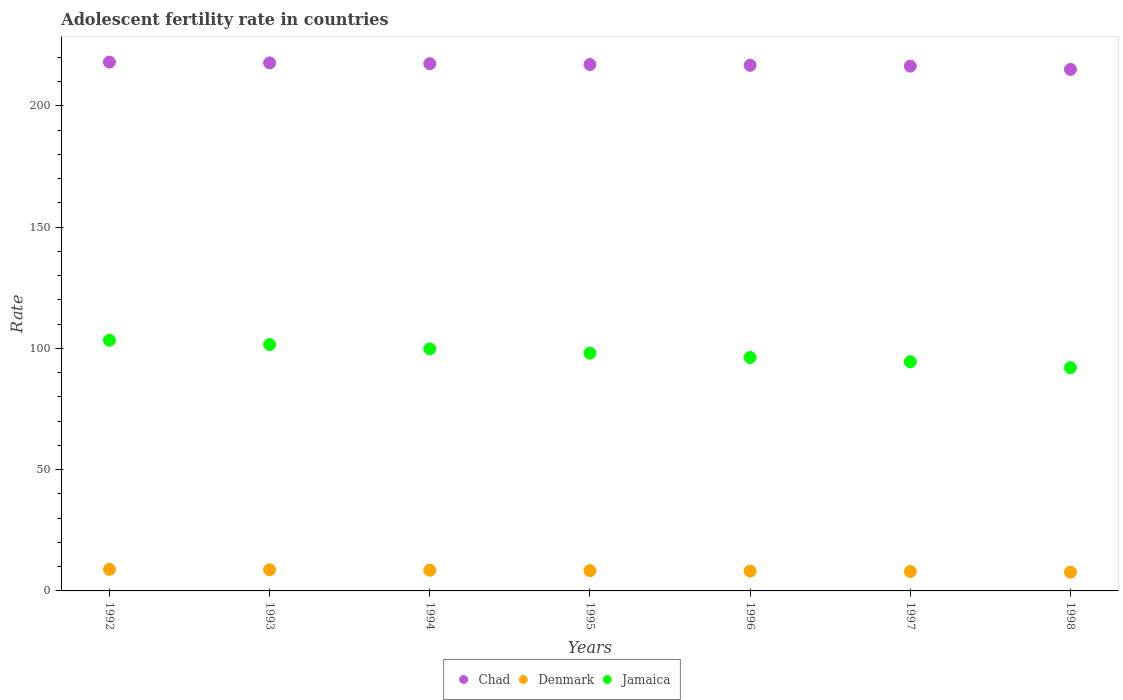How many different coloured dotlines are there?
Ensure brevity in your answer.  3. Is the number of dotlines equal to the number of legend labels?
Provide a short and direct response. Yes. What is the adolescent fertility rate in Denmark in 1997?
Your response must be concise. 8.01. Across all years, what is the maximum adolescent fertility rate in Jamaica?
Keep it short and to the point. 103.38. Across all years, what is the minimum adolescent fertility rate in Chad?
Provide a short and direct response. 215.09. In which year was the adolescent fertility rate in Chad minimum?
Make the answer very short. 1998. What is the total adolescent fertility rate in Jamaica in the graph?
Your answer should be very brief. 685.7. What is the difference between the adolescent fertility rate in Denmark in 1992 and that in 1998?
Keep it short and to the point. 1.17. What is the difference between the adolescent fertility rate in Chad in 1993 and the adolescent fertility rate in Jamaica in 1995?
Provide a succinct answer. 119.71. What is the average adolescent fertility rate in Denmark per year?
Provide a short and direct response. 8.35. In the year 1997, what is the difference between the adolescent fertility rate in Jamaica and adolescent fertility rate in Denmark?
Provide a short and direct response. 86.49. What is the ratio of the adolescent fertility rate in Jamaica in 1992 to that in 1996?
Offer a terse response. 1.07. Is the adolescent fertility rate in Chad in 1992 less than that in 1997?
Ensure brevity in your answer.  No. What is the difference between the highest and the second highest adolescent fertility rate in Chad?
Offer a very short reply. 0.33. What is the difference between the highest and the lowest adolescent fertility rate in Chad?
Ensure brevity in your answer.  3. Is it the case that in every year, the sum of the adolescent fertility rate in Denmark and adolescent fertility rate in Jamaica  is greater than the adolescent fertility rate in Chad?
Provide a short and direct response. No. Does the adolescent fertility rate in Jamaica monotonically increase over the years?
Your answer should be very brief. No. Is the adolescent fertility rate in Jamaica strictly greater than the adolescent fertility rate in Denmark over the years?
Your answer should be very brief. Yes. Is the adolescent fertility rate in Jamaica strictly less than the adolescent fertility rate in Chad over the years?
Ensure brevity in your answer.  Yes. How many years are there in the graph?
Keep it short and to the point. 7. What is the difference between two consecutive major ticks on the Y-axis?
Make the answer very short. 50. Are the values on the major ticks of Y-axis written in scientific E-notation?
Offer a very short reply. No. Does the graph contain any zero values?
Your response must be concise. No. Where does the legend appear in the graph?
Offer a terse response. Bottom center. How many legend labels are there?
Give a very brief answer. 3. How are the legend labels stacked?
Make the answer very short. Horizontal. What is the title of the graph?
Offer a terse response. Adolescent fertility rate in countries. What is the label or title of the Y-axis?
Give a very brief answer. Rate. What is the Rate in Chad in 1992?
Provide a short and direct response. 218.09. What is the Rate of Denmark in 1992?
Keep it short and to the point. 8.9. What is the Rate in Jamaica in 1992?
Keep it short and to the point. 103.38. What is the Rate of Chad in 1993?
Give a very brief answer. 217.76. What is the Rate of Denmark in 1993?
Your response must be concise. 8.72. What is the Rate in Jamaica in 1993?
Your answer should be compact. 101.6. What is the Rate in Chad in 1994?
Your answer should be compact. 217.43. What is the Rate in Denmark in 1994?
Give a very brief answer. 8.54. What is the Rate in Jamaica in 1994?
Ensure brevity in your answer.  99.83. What is the Rate of Chad in 1995?
Your response must be concise. 217.1. What is the Rate of Denmark in 1995?
Your response must be concise. 8.36. What is the Rate of Jamaica in 1995?
Make the answer very short. 98.05. What is the Rate of Chad in 1996?
Ensure brevity in your answer.  216.77. What is the Rate of Denmark in 1996?
Keep it short and to the point. 8.19. What is the Rate of Jamaica in 1996?
Offer a very short reply. 96.28. What is the Rate in Chad in 1997?
Offer a very short reply. 216.43. What is the Rate in Denmark in 1997?
Provide a succinct answer. 8.01. What is the Rate of Jamaica in 1997?
Offer a very short reply. 94.5. What is the Rate of Chad in 1998?
Offer a very short reply. 215.09. What is the Rate in Denmark in 1998?
Your answer should be very brief. 7.73. What is the Rate in Jamaica in 1998?
Ensure brevity in your answer.  92.07. Across all years, what is the maximum Rate in Chad?
Your answer should be compact. 218.09. Across all years, what is the maximum Rate in Denmark?
Keep it short and to the point. 8.9. Across all years, what is the maximum Rate of Jamaica?
Offer a very short reply. 103.38. Across all years, what is the minimum Rate of Chad?
Provide a succinct answer. 215.09. Across all years, what is the minimum Rate of Denmark?
Provide a short and direct response. 7.73. Across all years, what is the minimum Rate in Jamaica?
Give a very brief answer. 92.07. What is the total Rate in Chad in the graph?
Your answer should be compact. 1518.67. What is the total Rate in Denmark in the graph?
Provide a succinct answer. 58.45. What is the total Rate of Jamaica in the graph?
Provide a succinct answer. 685.7. What is the difference between the Rate of Chad in 1992 and that in 1993?
Keep it short and to the point. 0.33. What is the difference between the Rate in Denmark in 1992 and that in 1993?
Your answer should be compact. 0.18. What is the difference between the Rate of Jamaica in 1992 and that in 1993?
Provide a succinct answer. 1.78. What is the difference between the Rate of Chad in 1992 and that in 1994?
Provide a succinct answer. 0.66. What is the difference between the Rate in Denmark in 1992 and that in 1994?
Ensure brevity in your answer.  0.36. What is the difference between the Rate in Jamaica in 1992 and that in 1994?
Your answer should be very brief. 3.55. What is the difference between the Rate in Denmark in 1992 and that in 1995?
Your response must be concise. 0.54. What is the difference between the Rate of Jamaica in 1992 and that in 1995?
Your response must be concise. 5.33. What is the difference between the Rate in Chad in 1992 and that in 1996?
Your response must be concise. 1.33. What is the difference between the Rate in Denmark in 1992 and that in 1996?
Offer a terse response. 0.72. What is the difference between the Rate in Jamaica in 1992 and that in 1996?
Your answer should be compact. 7.1. What is the difference between the Rate in Chad in 1992 and that in 1997?
Ensure brevity in your answer.  1.66. What is the difference between the Rate of Denmark in 1992 and that in 1997?
Your answer should be very brief. 0.89. What is the difference between the Rate of Jamaica in 1992 and that in 1997?
Provide a short and direct response. 8.88. What is the difference between the Rate in Chad in 1992 and that in 1998?
Ensure brevity in your answer.  3. What is the difference between the Rate of Denmark in 1992 and that in 1998?
Keep it short and to the point. 1.17. What is the difference between the Rate of Jamaica in 1992 and that in 1998?
Ensure brevity in your answer.  11.3. What is the difference between the Rate in Chad in 1993 and that in 1994?
Keep it short and to the point. 0.33. What is the difference between the Rate of Denmark in 1993 and that in 1994?
Offer a very short reply. 0.18. What is the difference between the Rate of Jamaica in 1993 and that in 1994?
Your answer should be compact. 1.78. What is the difference between the Rate of Chad in 1993 and that in 1995?
Your response must be concise. 0.66. What is the difference between the Rate in Denmark in 1993 and that in 1995?
Ensure brevity in your answer.  0.36. What is the difference between the Rate of Jamaica in 1993 and that in 1995?
Offer a very short reply. 3.55. What is the difference between the Rate of Denmark in 1993 and that in 1996?
Make the answer very short. 0.54. What is the difference between the Rate of Jamaica in 1993 and that in 1996?
Offer a terse response. 5.33. What is the difference between the Rate of Chad in 1993 and that in 1997?
Offer a very short reply. 1.33. What is the difference between the Rate of Denmark in 1993 and that in 1997?
Your response must be concise. 0.72. What is the difference between the Rate in Jamaica in 1993 and that in 1997?
Provide a succinct answer. 7.1. What is the difference between the Rate of Chad in 1993 and that in 1998?
Provide a short and direct response. 2.67. What is the difference between the Rate of Denmark in 1993 and that in 1998?
Offer a terse response. 0.99. What is the difference between the Rate in Jamaica in 1993 and that in 1998?
Offer a very short reply. 9.53. What is the difference between the Rate in Chad in 1994 and that in 1995?
Keep it short and to the point. 0.33. What is the difference between the Rate of Denmark in 1994 and that in 1995?
Make the answer very short. 0.18. What is the difference between the Rate of Jamaica in 1994 and that in 1995?
Your answer should be very brief. 1.78. What is the difference between the Rate in Chad in 1994 and that in 1996?
Your answer should be compact. 0.66. What is the difference between the Rate of Denmark in 1994 and that in 1996?
Make the answer very short. 0.36. What is the difference between the Rate in Jamaica in 1994 and that in 1996?
Your answer should be very brief. 3.55. What is the difference between the Rate of Chad in 1994 and that in 1997?
Keep it short and to the point. 1. What is the difference between the Rate of Denmark in 1994 and that in 1997?
Provide a succinct answer. 0.54. What is the difference between the Rate of Jamaica in 1994 and that in 1997?
Ensure brevity in your answer.  5.33. What is the difference between the Rate of Chad in 1994 and that in 1998?
Offer a very short reply. 2.34. What is the difference between the Rate in Denmark in 1994 and that in 1998?
Keep it short and to the point. 0.81. What is the difference between the Rate of Jamaica in 1994 and that in 1998?
Keep it short and to the point. 7.75. What is the difference between the Rate of Chad in 1995 and that in 1996?
Your response must be concise. 0.33. What is the difference between the Rate in Denmark in 1995 and that in 1996?
Offer a very short reply. 0.18. What is the difference between the Rate in Jamaica in 1995 and that in 1996?
Offer a very short reply. 1.78. What is the difference between the Rate in Chad in 1995 and that in 1997?
Your response must be concise. 0.66. What is the difference between the Rate of Denmark in 1995 and that in 1997?
Give a very brief answer. 0.36. What is the difference between the Rate in Jamaica in 1995 and that in 1997?
Make the answer very short. 3.55. What is the difference between the Rate of Chad in 1995 and that in 1998?
Offer a terse response. 2.01. What is the difference between the Rate in Denmark in 1995 and that in 1998?
Provide a short and direct response. 0.64. What is the difference between the Rate in Jamaica in 1995 and that in 1998?
Give a very brief answer. 5.98. What is the difference between the Rate of Chad in 1996 and that in 1997?
Offer a terse response. 0.33. What is the difference between the Rate of Denmark in 1996 and that in 1997?
Provide a succinct answer. 0.18. What is the difference between the Rate of Jamaica in 1996 and that in 1997?
Make the answer very short. 1.78. What is the difference between the Rate of Chad in 1996 and that in 1998?
Provide a succinct answer. 1.67. What is the difference between the Rate in Denmark in 1996 and that in 1998?
Make the answer very short. 0.46. What is the difference between the Rate of Jamaica in 1996 and that in 1998?
Make the answer very short. 4.2. What is the difference between the Rate of Chad in 1997 and that in 1998?
Offer a very short reply. 1.34. What is the difference between the Rate of Denmark in 1997 and that in 1998?
Make the answer very short. 0.28. What is the difference between the Rate of Jamaica in 1997 and that in 1998?
Your answer should be very brief. 2.43. What is the difference between the Rate in Chad in 1992 and the Rate in Denmark in 1993?
Offer a very short reply. 209.37. What is the difference between the Rate in Chad in 1992 and the Rate in Jamaica in 1993?
Offer a terse response. 116.49. What is the difference between the Rate in Denmark in 1992 and the Rate in Jamaica in 1993?
Your answer should be compact. -92.7. What is the difference between the Rate in Chad in 1992 and the Rate in Denmark in 1994?
Offer a terse response. 209.55. What is the difference between the Rate of Chad in 1992 and the Rate of Jamaica in 1994?
Keep it short and to the point. 118.27. What is the difference between the Rate of Denmark in 1992 and the Rate of Jamaica in 1994?
Offer a terse response. -90.92. What is the difference between the Rate in Chad in 1992 and the Rate in Denmark in 1995?
Your response must be concise. 209.73. What is the difference between the Rate in Chad in 1992 and the Rate in Jamaica in 1995?
Give a very brief answer. 120.04. What is the difference between the Rate in Denmark in 1992 and the Rate in Jamaica in 1995?
Provide a succinct answer. -89.15. What is the difference between the Rate of Chad in 1992 and the Rate of Denmark in 1996?
Make the answer very short. 209.91. What is the difference between the Rate of Chad in 1992 and the Rate of Jamaica in 1996?
Offer a terse response. 121.82. What is the difference between the Rate in Denmark in 1992 and the Rate in Jamaica in 1996?
Offer a terse response. -87.37. What is the difference between the Rate in Chad in 1992 and the Rate in Denmark in 1997?
Your response must be concise. 210.09. What is the difference between the Rate in Chad in 1992 and the Rate in Jamaica in 1997?
Offer a terse response. 123.59. What is the difference between the Rate in Denmark in 1992 and the Rate in Jamaica in 1997?
Your response must be concise. -85.6. What is the difference between the Rate in Chad in 1992 and the Rate in Denmark in 1998?
Ensure brevity in your answer.  210.36. What is the difference between the Rate of Chad in 1992 and the Rate of Jamaica in 1998?
Ensure brevity in your answer.  126.02. What is the difference between the Rate in Denmark in 1992 and the Rate in Jamaica in 1998?
Provide a succinct answer. -83.17. What is the difference between the Rate of Chad in 1993 and the Rate of Denmark in 1994?
Offer a very short reply. 209.22. What is the difference between the Rate of Chad in 1993 and the Rate of Jamaica in 1994?
Your answer should be compact. 117.94. What is the difference between the Rate of Denmark in 1993 and the Rate of Jamaica in 1994?
Offer a terse response. -91.1. What is the difference between the Rate of Chad in 1993 and the Rate of Denmark in 1995?
Ensure brevity in your answer.  209.4. What is the difference between the Rate in Chad in 1993 and the Rate in Jamaica in 1995?
Your response must be concise. 119.71. What is the difference between the Rate of Denmark in 1993 and the Rate of Jamaica in 1995?
Your answer should be very brief. -89.33. What is the difference between the Rate of Chad in 1993 and the Rate of Denmark in 1996?
Offer a terse response. 209.58. What is the difference between the Rate of Chad in 1993 and the Rate of Jamaica in 1996?
Make the answer very short. 121.49. What is the difference between the Rate in Denmark in 1993 and the Rate in Jamaica in 1996?
Offer a terse response. -87.55. What is the difference between the Rate in Chad in 1993 and the Rate in Denmark in 1997?
Provide a succinct answer. 209.75. What is the difference between the Rate of Chad in 1993 and the Rate of Jamaica in 1997?
Keep it short and to the point. 123.26. What is the difference between the Rate of Denmark in 1993 and the Rate of Jamaica in 1997?
Give a very brief answer. -85.78. What is the difference between the Rate of Chad in 1993 and the Rate of Denmark in 1998?
Provide a short and direct response. 210.03. What is the difference between the Rate in Chad in 1993 and the Rate in Jamaica in 1998?
Provide a succinct answer. 125.69. What is the difference between the Rate in Denmark in 1993 and the Rate in Jamaica in 1998?
Your answer should be very brief. -83.35. What is the difference between the Rate in Chad in 1994 and the Rate in Denmark in 1995?
Keep it short and to the point. 209.06. What is the difference between the Rate of Chad in 1994 and the Rate of Jamaica in 1995?
Your answer should be very brief. 119.38. What is the difference between the Rate in Denmark in 1994 and the Rate in Jamaica in 1995?
Provide a short and direct response. -89.51. What is the difference between the Rate in Chad in 1994 and the Rate in Denmark in 1996?
Your response must be concise. 209.24. What is the difference between the Rate of Chad in 1994 and the Rate of Jamaica in 1996?
Your answer should be very brief. 121.15. What is the difference between the Rate of Denmark in 1994 and the Rate of Jamaica in 1996?
Ensure brevity in your answer.  -87.73. What is the difference between the Rate in Chad in 1994 and the Rate in Denmark in 1997?
Your answer should be very brief. 209.42. What is the difference between the Rate in Chad in 1994 and the Rate in Jamaica in 1997?
Your answer should be very brief. 122.93. What is the difference between the Rate of Denmark in 1994 and the Rate of Jamaica in 1997?
Ensure brevity in your answer.  -85.96. What is the difference between the Rate in Chad in 1994 and the Rate in Denmark in 1998?
Offer a terse response. 209.7. What is the difference between the Rate of Chad in 1994 and the Rate of Jamaica in 1998?
Your answer should be very brief. 125.36. What is the difference between the Rate in Denmark in 1994 and the Rate in Jamaica in 1998?
Your answer should be very brief. -83.53. What is the difference between the Rate of Chad in 1995 and the Rate of Denmark in 1996?
Give a very brief answer. 208.91. What is the difference between the Rate in Chad in 1995 and the Rate in Jamaica in 1996?
Make the answer very short. 120.82. What is the difference between the Rate in Denmark in 1995 and the Rate in Jamaica in 1996?
Keep it short and to the point. -87.91. What is the difference between the Rate of Chad in 1995 and the Rate of Denmark in 1997?
Provide a succinct answer. 209.09. What is the difference between the Rate of Chad in 1995 and the Rate of Jamaica in 1997?
Your answer should be compact. 122.6. What is the difference between the Rate in Denmark in 1995 and the Rate in Jamaica in 1997?
Your answer should be compact. -86.14. What is the difference between the Rate in Chad in 1995 and the Rate in Denmark in 1998?
Provide a succinct answer. 209.37. What is the difference between the Rate of Chad in 1995 and the Rate of Jamaica in 1998?
Give a very brief answer. 125.02. What is the difference between the Rate in Denmark in 1995 and the Rate in Jamaica in 1998?
Make the answer very short. -83.71. What is the difference between the Rate in Chad in 1996 and the Rate in Denmark in 1997?
Make the answer very short. 208.76. What is the difference between the Rate in Chad in 1996 and the Rate in Jamaica in 1997?
Keep it short and to the point. 122.27. What is the difference between the Rate of Denmark in 1996 and the Rate of Jamaica in 1997?
Offer a terse response. -86.31. What is the difference between the Rate of Chad in 1996 and the Rate of Denmark in 1998?
Make the answer very short. 209.04. What is the difference between the Rate of Chad in 1996 and the Rate of Jamaica in 1998?
Offer a terse response. 124.69. What is the difference between the Rate of Denmark in 1996 and the Rate of Jamaica in 1998?
Provide a short and direct response. -83.89. What is the difference between the Rate in Chad in 1997 and the Rate in Denmark in 1998?
Your answer should be compact. 208.7. What is the difference between the Rate in Chad in 1997 and the Rate in Jamaica in 1998?
Make the answer very short. 124.36. What is the difference between the Rate of Denmark in 1997 and the Rate of Jamaica in 1998?
Offer a very short reply. -84.07. What is the average Rate in Chad per year?
Provide a short and direct response. 216.95. What is the average Rate in Denmark per year?
Offer a terse response. 8.35. What is the average Rate of Jamaica per year?
Make the answer very short. 97.96. In the year 1992, what is the difference between the Rate of Chad and Rate of Denmark?
Keep it short and to the point. 209.19. In the year 1992, what is the difference between the Rate in Chad and Rate in Jamaica?
Give a very brief answer. 114.72. In the year 1992, what is the difference between the Rate of Denmark and Rate of Jamaica?
Keep it short and to the point. -94.47. In the year 1993, what is the difference between the Rate of Chad and Rate of Denmark?
Offer a terse response. 209.04. In the year 1993, what is the difference between the Rate in Chad and Rate in Jamaica?
Provide a succinct answer. 116.16. In the year 1993, what is the difference between the Rate of Denmark and Rate of Jamaica?
Provide a short and direct response. -92.88. In the year 1994, what is the difference between the Rate in Chad and Rate in Denmark?
Offer a terse response. 208.89. In the year 1994, what is the difference between the Rate of Chad and Rate of Jamaica?
Offer a very short reply. 117.6. In the year 1994, what is the difference between the Rate in Denmark and Rate in Jamaica?
Give a very brief answer. -91.28. In the year 1995, what is the difference between the Rate of Chad and Rate of Denmark?
Make the answer very short. 208.73. In the year 1995, what is the difference between the Rate in Chad and Rate in Jamaica?
Your answer should be compact. 119.05. In the year 1995, what is the difference between the Rate in Denmark and Rate in Jamaica?
Your response must be concise. -89.69. In the year 1996, what is the difference between the Rate of Chad and Rate of Denmark?
Your response must be concise. 208.58. In the year 1996, what is the difference between the Rate of Chad and Rate of Jamaica?
Provide a succinct answer. 120.49. In the year 1996, what is the difference between the Rate of Denmark and Rate of Jamaica?
Your answer should be very brief. -88.09. In the year 1997, what is the difference between the Rate in Chad and Rate in Denmark?
Provide a succinct answer. 208.43. In the year 1997, what is the difference between the Rate of Chad and Rate of Jamaica?
Ensure brevity in your answer.  121.93. In the year 1997, what is the difference between the Rate of Denmark and Rate of Jamaica?
Give a very brief answer. -86.49. In the year 1998, what is the difference between the Rate in Chad and Rate in Denmark?
Provide a succinct answer. 207.36. In the year 1998, what is the difference between the Rate of Chad and Rate of Jamaica?
Ensure brevity in your answer.  123.02. In the year 1998, what is the difference between the Rate in Denmark and Rate in Jamaica?
Offer a terse response. -84.34. What is the ratio of the Rate of Denmark in 1992 to that in 1993?
Your answer should be compact. 1.02. What is the ratio of the Rate of Jamaica in 1992 to that in 1993?
Provide a short and direct response. 1.02. What is the ratio of the Rate of Denmark in 1992 to that in 1994?
Make the answer very short. 1.04. What is the ratio of the Rate in Jamaica in 1992 to that in 1994?
Your answer should be compact. 1.04. What is the ratio of the Rate of Chad in 1992 to that in 1995?
Make the answer very short. 1. What is the ratio of the Rate in Denmark in 1992 to that in 1995?
Provide a succinct answer. 1.06. What is the ratio of the Rate in Jamaica in 1992 to that in 1995?
Keep it short and to the point. 1.05. What is the ratio of the Rate of Denmark in 1992 to that in 1996?
Offer a terse response. 1.09. What is the ratio of the Rate of Jamaica in 1992 to that in 1996?
Provide a succinct answer. 1.07. What is the ratio of the Rate of Chad in 1992 to that in 1997?
Provide a short and direct response. 1.01. What is the ratio of the Rate of Denmark in 1992 to that in 1997?
Offer a terse response. 1.11. What is the ratio of the Rate of Jamaica in 1992 to that in 1997?
Your answer should be compact. 1.09. What is the ratio of the Rate in Denmark in 1992 to that in 1998?
Offer a very short reply. 1.15. What is the ratio of the Rate in Jamaica in 1992 to that in 1998?
Give a very brief answer. 1.12. What is the ratio of the Rate in Denmark in 1993 to that in 1994?
Make the answer very short. 1.02. What is the ratio of the Rate in Jamaica in 1993 to that in 1994?
Offer a very short reply. 1.02. What is the ratio of the Rate in Denmark in 1993 to that in 1995?
Ensure brevity in your answer.  1.04. What is the ratio of the Rate in Jamaica in 1993 to that in 1995?
Give a very brief answer. 1.04. What is the ratio of the Rate of Denmark in 1993 to that in 1996?
Offer a terse response. 1.07. What is the ratio of the Rate of Jamaica in 1993 to that in 1996?
Your response must be concise. 1.06. What is the ratio of the Rate of Denmark in 1993 to that in 1997?
Offer a very short reply. 1.09. What is the ratio of the Rate of Jamaica in 1993 to that in 1997?
Make the answer very short. 1.08. What is the ratio of the Rate of Chad in 1993 to that in 1998?
Keep it short and to the point. 1.01. What is the ratio of the Rate in Denmark in 1993 to that in 1998?
Your answer should be very brief. 1.13. What is the ratio of the Rate in Jamaica in 1993 to that in 1998?
Offer a terse response. 1.1. What is the ratio of the Rate in Denmark in 1994 to that in 1995?
Give a very brief answer. 1.02. What is the ratio of the Rate of Jamaica in 1994 to that in 1995?
Keep it short and to the point. 1.02. What is the ratio of the Rate of Denmark in 1994 to that in 1996?
Provide a short and direct response. 1.04. What is the ratio of the Rate of Jamaica in 1994 to that in 1996?
Provide a short and direct response. 1.04. What is the ratio of the Rate of Denmark in 1994 to that in 1997?
Make the answer very short. 1.07. What is the ratio of the Rate in Jamaica in 1994 to that in 1997?
Give a very brief answer. 1.06. What is the ratio of the Rate of Chad in 1994 to that in 1998?
Provide a short and direct response. 1.01. What is the ratio of the Rate in Denmark in 1994 to that in 1998?
Provide a short and direct response. 1.11. What is the ratio of the Rate in Jamaica in 1994 to that in 1998?
Ensure brevity in your answer.  1.08. What is the ratio of the Rate in Denmark in 1995 to that in 1996?
Your answer should be very brief. 1.02. What is the ratio of the Rate of Jamaica in 1995 to that in 1996?
Your answer should be very brief. 1.02. What is the ratio of the Rate in Chad in 1995 to that in 1997?
Offer a very short reply. 1. What is the ratio of the Rate in Denmark in 1995 to that in 1997?
Offer a terse response. 1.04. What is the ratio of the Rate in Jamaica in 1995 to that in 1997?
Ensure brevity in your answer.  1.04. What is the ratio of the Rate in Chad in 1995 to that in 1998?
Your answer should be compact. 1.01. What is the ratio of the Rate in Denmark in 1995 to that in 1998?
Make the answer very short. 1.08. What is the ratio of the Rate of Jamaica in 1995 to that in 1998?
Offer a very short reply. 1.06. What is the ratio of the Rate in Chad in 1996 to that in 1997?
Give a very brief answer. 1. What is the ratio of the Rate in Denmark in 1996 to that in 1997?
Provide a short and direct response. 1.02. What is the ratio of the Rate in Jamaica in 1996 to that in 1997?
Keep it short and to the point. 1.02. What is the ratio of the Rate in Chad in 1996 to that in 1998?
Your answer should be very brief. 1.01. What is the ratio of the Rate in Denmark in 1996 to that in 1998?
Your response must be concise. 1.06. What is the ratio of the Rate in Jamaica in 1996 to that in 1998?
Your response must be concise. 1.05. What is the ratio of the Rate of Chad in 1997 to that in 1998?
Make the answer very short. 1.01. What is the ratio of the Rate of Denmark in 1997 to that in 1998?
Make the answer very short. 1.04. What is the ratio of the Rate in Jamaica in 1997 to that in 1998?
Offer a terse response. 1.03. What is the difference between the highest and the second highest Rate of Chad?
Provide a succinct answer. 0.33. What is the difference between the highest and the second highest Rate in Denmark?
Provide a succinct answer. 0.18. What is the difference between the highest and the second highest Rate in Jamaica?
Keep it short and to the point. 1.78. What is the difference between the highest and the lowest Rate in Chad?
Keep it short and to the point. 3. What is the difference between the highest and the lowest Rate of Denmark?
Give a very brief answer. 1.17. What is the difference between the highest and the lowest Rate of Jamaica?
Give a very brief answer. 11.3. 